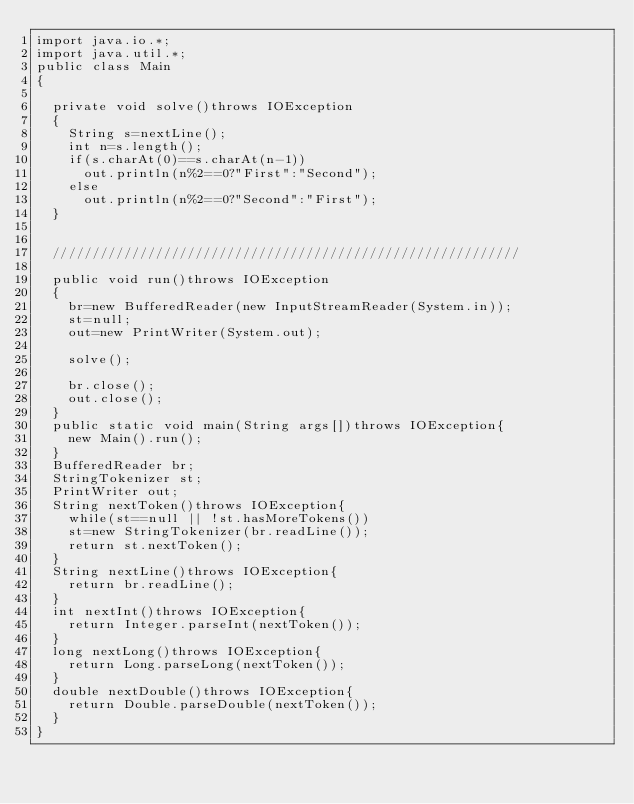Convert code to text. <code><loc_0><loc_0><loc_500><loc_500><_Java_>import java.io.*;
import java.util.*;
public class Main
{
	
	private void solve()throws IOException
	{
		String s=nextLine();
		int n=s.length();
		if(s.charAt(0)==s.charAt(n-1))
			out.println(n%2==0?"First":"Second");
		else
			out.println(n%2==0?"Second":"First");
	}

	 
	///////////////////////////////////////////////////////////

	public void run()throws IOException
	{
		br=new BufferedReader(new InputStreamReader(System.in));
		st=null;
		out=new PrintWriter(System.out);

		solve();
		
		br.close();
		out.close();
	}
	public static void main(String args[])throws IOException{
		new Main().run();
	}
	BufferedReader br;
	StringTokenizer st;
	PrintWriter out;
	String nextToken()throws IOException{
		while(st==null || !st.hasMoreTokens())
		st=new StringTokenizer(br.readLine());
		return st.nextToken();
	}
	String nextLine()throws IOException{
		return br.readLine();
	}
	int nextInt()throws IOException{
		return Integer.parseInt(nextToken());
	}
	long nextLong()throws IOException{
		return Long.parseLong(nextToken());
	}
	double nextDouble()throws IOException{
		return Double.parseDouble(nextToken());
	}
}</code> 